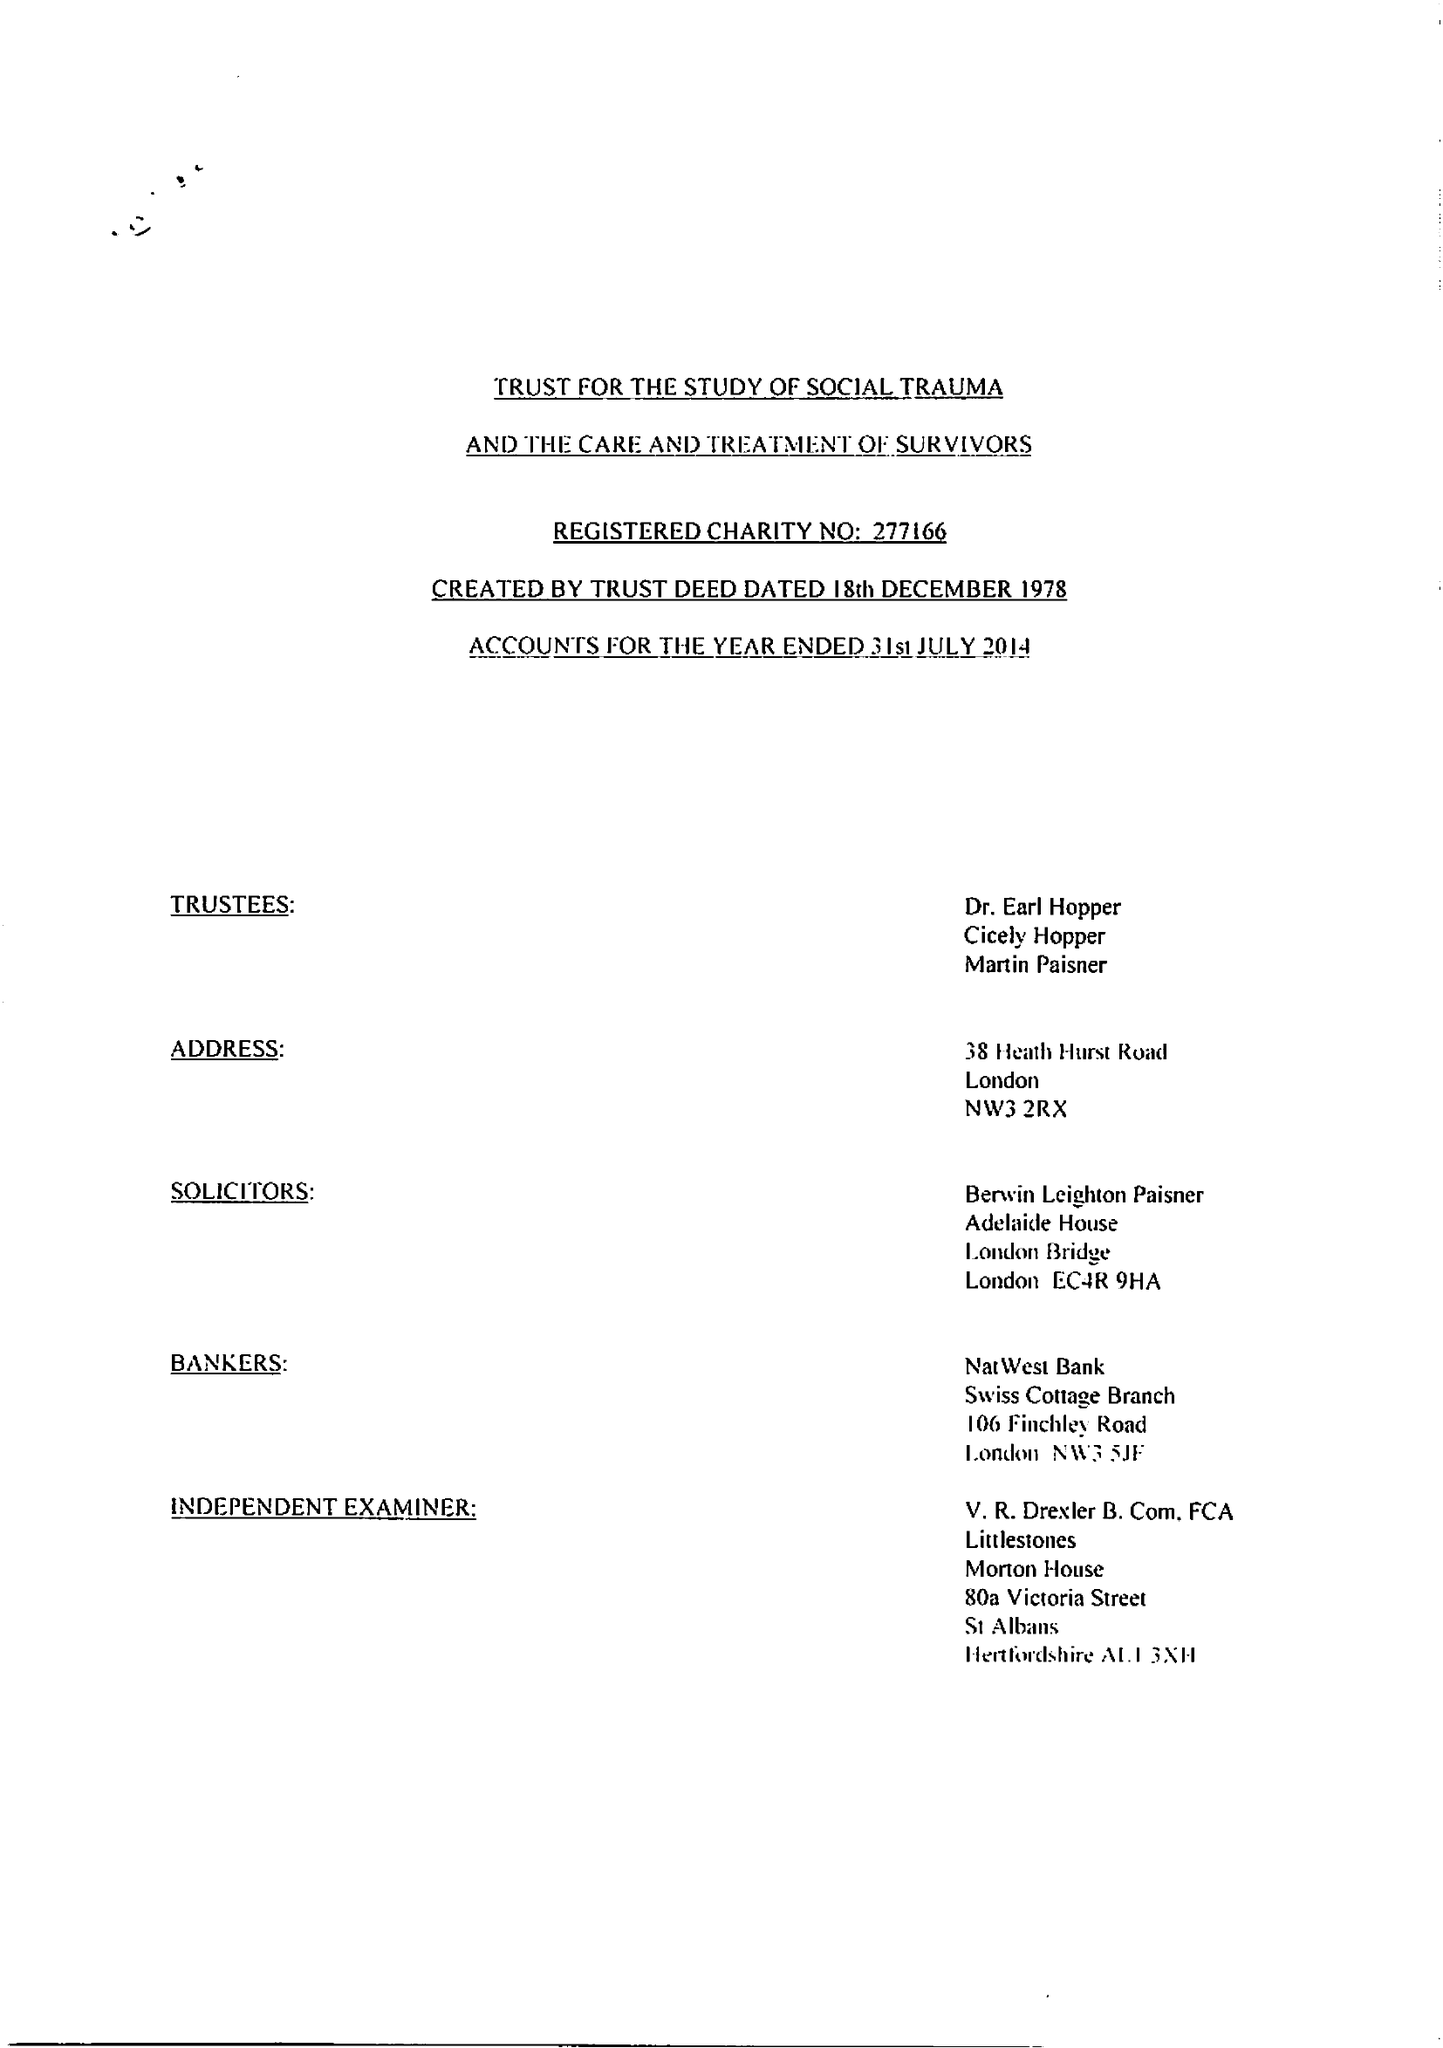What is the value for the income_annually_in_british_pounds?
Answer the question using a single word or phrase. 29703.00 